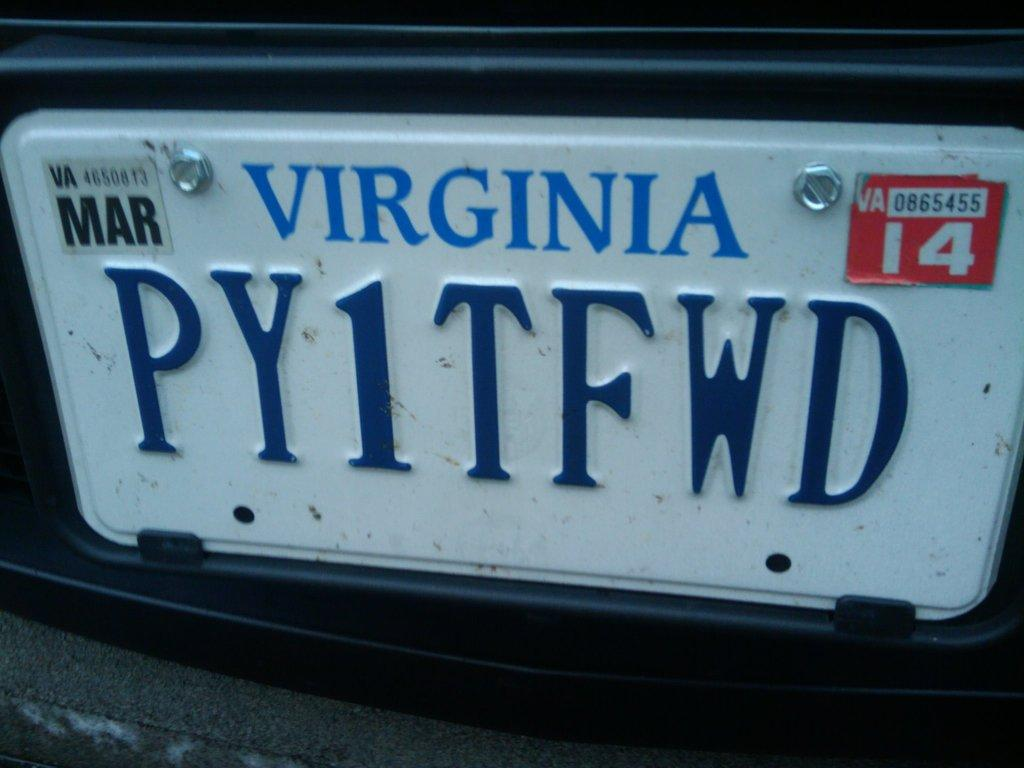What can be seen in the image that is related to identification or registration? There is a number plate in the image. What is the color of the number plate? The number plate is white in color. Is the number plate connected to anything? Yes, the number plate is attached to an object. What information is displayed on the number plate? There is writing on the number plate. What is the texture of the weather in the image? The image does not depict weather, and therefore, there is no texture to describe. 